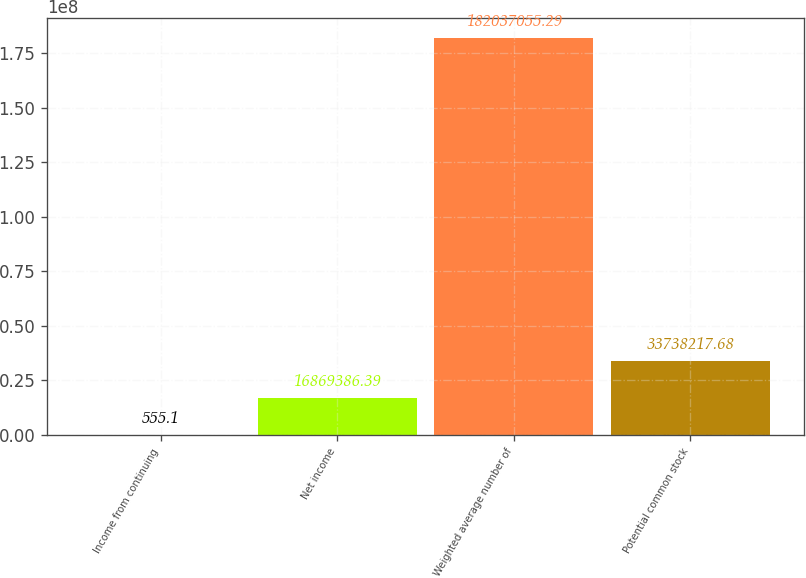<chart> <loc_0><loc_0><loc_500><loc_500><bar_chart><fcel>Income from continuing<fcel>Net income<fcel>Weighted average number of<fcel>Potential common stock<nl><fcel>555.1<fcel>1.68694e+07<fcel>1.82037e+08<fcel>3.37382e+07<nl></chart> 